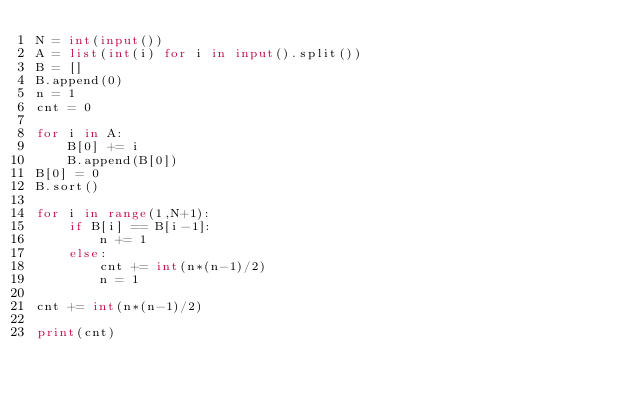Convert code to text. <code><loc_0><loc_0><loc_500><loc_500><_Python_>N = int(input())
A = list(int(i) for i in input().split())
B = []
B.append(0)
n = 1
cnt = 0

for i in A:
    B[0] += i
    B.append(B[0])
B[0] = 0
B.sort()

for i in range(1,N+1):
    if B[i] == B[i-1]:
        n += 1
    else:
        cnt += int(n*(n-1)/2)
        n = 1

cnt += int(n*(n-1)/2)

print(cnt)</code> 